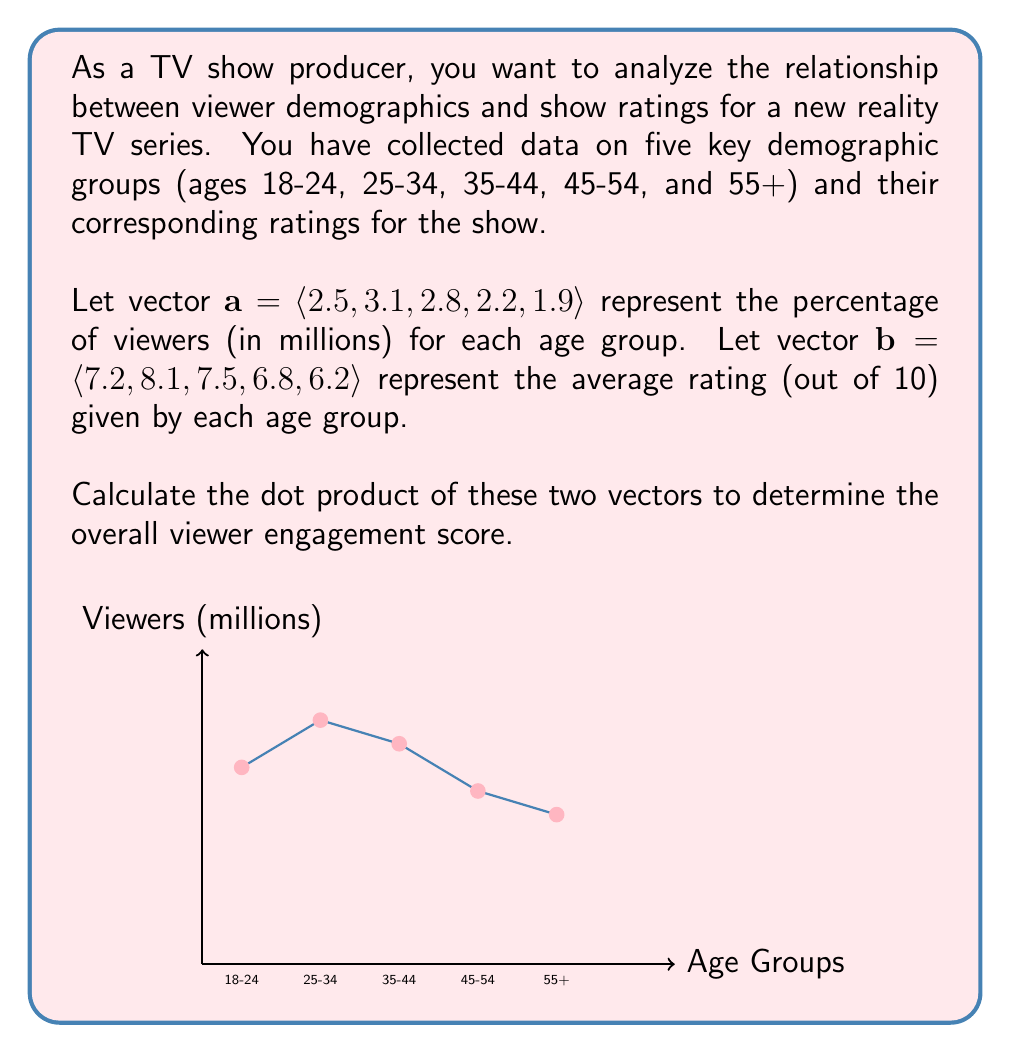Teach me how to tackle this problem. To solve this problem, we need to calculate the dot product of vectors $\mathbf{a}$ and $\mathbf{b}$. The dot product is a scalar value that represents the sum of the products of corresponding elements in two vectors.

Step 1: Recall the formula for the dot product of two vectors:
$$\mathbf{a} \cdot \mathbf{b} = a_1b_1 + a_2b_2 + a_3b_3 + a_4b_4 + a_5b_5$$

Step 2: Substitute the values from the given vectors:
$$\mathbf{a} \cdot \mathbf{b} = (2.5 \times 7.2) + (3.1 \times 8.1) + (2.8 \times 7.5) + (2.2 \times 6.8) + (1.9 \times 6.2)$$

Step 3: Multiply each pair of corresponding elements:
$$\mathbf{a} \cdot \mathbf{b} = 18.0 + 25.11 + 21.0 + 14.96 + 11.78$$

Step 4: Sum up all the products:
$$\mathbf{a} \cdot \mathbf{b} = 90.85$$

The resulting scalar value, 90.85, represents the overall viewer engagement score, taking into account both the number of viewers in each age group and their respective ratings for the show.
Answer: $90.85$ 